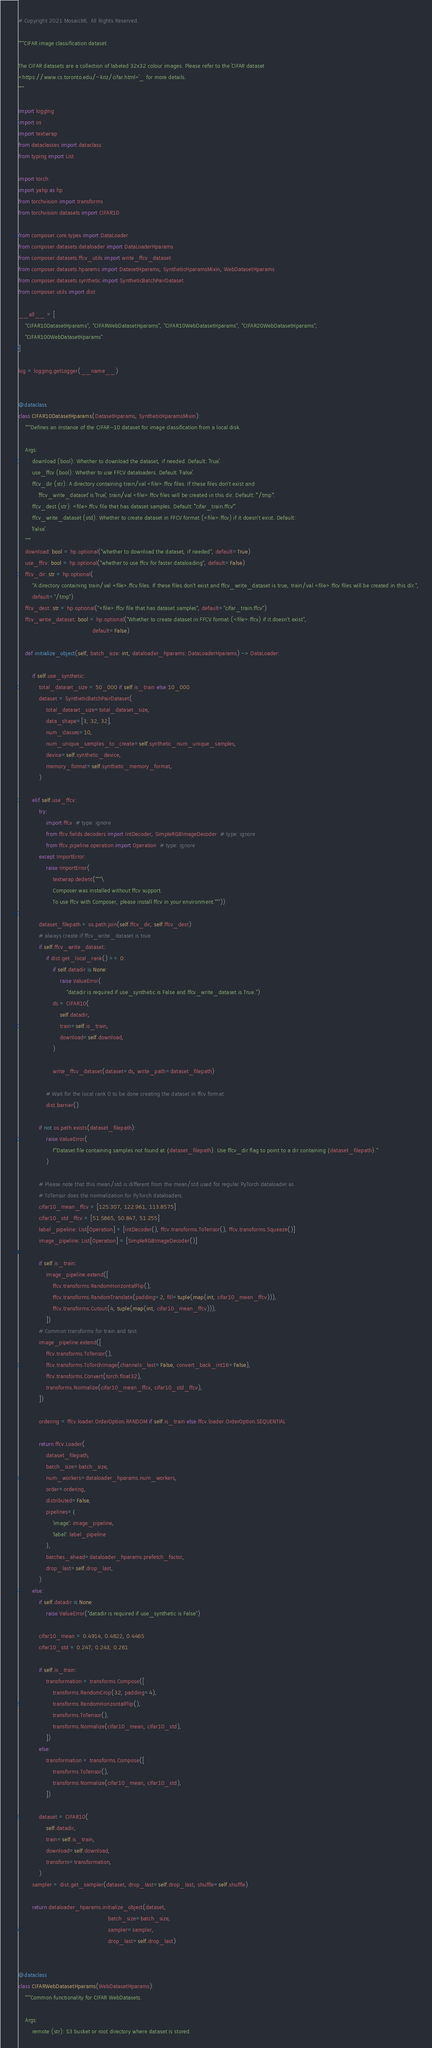Convert code to text. <code><loc_0><loc_0><loc_500><loc_500><_Python_># Copyright 2021 MosaicML. All Rights Reserved.

"""CIFAR image classification dataset.

The CIFAR datasets are a collection of labeled 32x32 colour images. Please refer to the `CIFAR dataset
<https://www.cs.toronto.edu/~kriz/cifar.html>`_ for more details.
"""

import logging
import os
import textwrap
from dataclasses import dataclass
from typing import List

import torch
import yahp as hp
from torchvision import transforms
from torchvision.datasets import CIFAR10

from composer.core.types import DataLoader
from composer.datasets.dataloader import DataLoaderHparams
from composer.datasets.ffcv_utils import write_ffcv_dataset
from composer.datasets.hparams import DatasetHparams, SyntheticHparamsMixin, WebDatasetHparams
from composer.datasets.synthetic import SyntheticBatchPairDataset
from composer.utils import dist

__all__ = [
    "CIFAR10DatasetHparams", "CIFARWebDatasetHparams", "CIFAR10WebDatasetHparams", "CIFAR20WebDatasetHparams",
    "CIFAR100WebDatasetHparams"
]

log = logging.getLogger(__name__)


@dataclass
class CIFAR10DatasetHparams(DatasetHparams, SyntheticHparamsMixin):
    """Defines an instance of the CIFAR-10 dataset for image classification from a local disk.

    Args:
        download (bool): Whether to download the dataset, if needed. Default: ``True``.
        use_ffcv (bool): Whether to use FFCV dataloaders. Default: ``False``.
        ffcv_dir (str): A directory containing train/val <file>.ffcv files. If these files don't exist and
            ``ffcv_write_dataset`` is ``True``, train/val <file>.ffcv files will be created in this dir. Default: ``"/tmp"``.
        ffcv_dest (str): <file>.ffcv file that has dataset samples. Default: ``"cifar_train.ffcv"``.
        ffcv_write_dataset (std): Whether to create dataset in FFCV format (<file>.ffcv) if it doesn't exist. Default:
        ``False``.
    """
    download: bool = hp.optional("whether to download the dataset, if needed", default=True)
    use_ffcv: bool = hp.optional("whether to use ffcv for faster dataloading", default=False)
    ffcv_dir: str = hp.optional(
        "A directory containing train/val <file>.ffcv files. If these files don't exist and ffcv_write_dataset is true, train/val <file>.ffcv files will be created in this dir.",
        default="/tmp")
    ffcv_dest: str = hp.optional("<file>.ffcv file that has dataset samples", default="cifar_train.ffcv")
    ffcv_write_dataset: bool = hp.optional("Whether to create dataset in FFCV format (<file>.ffcv) if it doesn't exist",
                                           default=False)

    def initialize_object(self, batch_size: int, dataloader_hparams: DataLoaderHparams) -> DataLoader:

        if self.use_synthetic:
            total_dataset_size = 50_000 if self.is_train else 10_000
            dataset = SyntheticBatchPairDataset(
                total_dataset_size=total_dataset_size,
                data_shape=[3, 32, 32],
                num_classes=10,
                num_unique_samples_to_create=self.synthetic_num_unique_samples,
                device=self.synthetic_device,
                memory_format=self.synthetic_memory_format,
            )

        elif self.use_ffcv:
            try:
                import ffcv  # type: ignore
                from ffcv.fields.decoders import IntDecoder, SimpleRGBImageDecoder  # type: ignore
                from ffcv.pipeline.operation import Operation  # type: ignore
            except ImportError:
                raise ImportError(
                    textwrap.dedent("""\
                    Composer was installed without ffcv support.
                    To use ffcv with Composer, please install ffcv in your environment."""))

            dataset_filepath = os.path.join(self.ffcv_dir, self.ffcv_dest)
            # always create if ffcv_write_dataset is true
            if self.ffcv_write_dataset:
                if dist.get_local_rank() == 0:
                    if self.datadir is None:
                        raise ValueError(
                            "datadir is required if use_synthetic is False and ffcv_write_dataset is True.")
                    ds = CIFAR10(
                        self.datadir,
                        train=self.is_train,
                        download=self.download,
                    )

                    write_ffcv_dataset(dataset=ds, write_path=dataset_filepath)

                # Wait for the local rank 0 to be done creating the dataset in ffcv format.
                dist.barrier()

            if not os.path.exists(dataset_filepath):
                raise ValueError(
                    f"Dataset file containing samples not found at {dataset_filepath}. Use ffcv_dir flag to point to a dir containing {dataset_filepath}."
                )

            # Please note that this mean/std is different from the mean/std used for regular PyTorch dataloader as
            # ToTensor does the normalization for PyTorch dataloaders.
            cifar10_mean_ffcv = [125.307, 122.961, 113.8575]
            cifar10_std_ffcv = [51.5865, 50.847, 51.255]
            label_pipeline: List[Operation] = [IntDecoder(), ffcv.transforms.ToTensor(), ffcv.transforms.Squeeze()]
            image_pipeline: List[Operation] = [SimpleRGBImageDecoder()]

            if self.is_train:
                image_pipeline.extend([
                    ffcv.transforms.RandomHorizontalFlip(),
                    ffcv.transforms.RandomTranslate(padding=2, fill=tuple(map(int, cifar10_mean_ffcv))),
                    ffcv.transforms.Cutout(4, tuple(map(int, cifar10_mean_ffcv))),
                ])
            # Common transforms for train and test
            image_pipeline.extend([
                ffcv.transforms.ToTensor(),
                ffcv.transforms.ToTorchImage(channels_last=False, convert_back_int16=False),
                ffcv.transforms.Convert(torch.float32),
                transforms.Normalize(cifar10_mean_ffcv, cifar10_std_ffcv),
            ])

            ordering = ffcv.loader.OrderOption.RANDOM if self.is_train else ffcv.loader.OrderOption.SEQUENTIAL

            return ffcv.Loader(
                dataset_filepath,
                batch_size=batch_size,
                num_workers=dataloader_hparams.num_workers,
                order=ordering,
                distributed=False,
                pipelines={
                    'image': image_pipeline,
                    'label': label_pipeline
                },
                batches_ahead=dataloader_hparams.prefetch_factor,
                drop_last=self.drop_last,
            )
        else:
            if self.datadir is None:
                raise ValueError("datadir is required if use_synthetic is False")

            cifar10_mean = 0.4914, 0.4822, 0.4465
            cifar10_std = 0.247, 0.243, 0.261

            if self.is_train:
                transformation = transforms.Compose([
                    transforms.RandomCrop(32, padding=4),
                    transforms.RandomHorizontalFlip(),
                    transforms.ToTensor(),
                    transforms.Normalize(cifar10_mean, cifar10_std),
                ])
            else:
                transformation = transforms.Compose([
                    transforms.ToTensor(),
                    transforms.Normalize(cifar10_mean, cifar10_std),
                ])

            dataset = CIFAR10(
                self.datadir,
                train=self.is_train,
                download=self.download,
                transform=transformation,
            )
        sampler = dist.get_sampler(dataset, drop_last=self.drop_last, shuffle=self.shuffle)

        return dataloader_hparams.initialize_object(dataset,
                                                    batch_size=batch_size,
                                                    sampler=sampler,
                                                    drop_last=self.drop_last)


@dataclass
class CIFARWebDatasetHparams(WebDatasetHparams):
    """Common functionality for CIFAR WebDatasets.

    Args:
        remote (str): S3 bucket or root directory where dataset is stored.</code> 